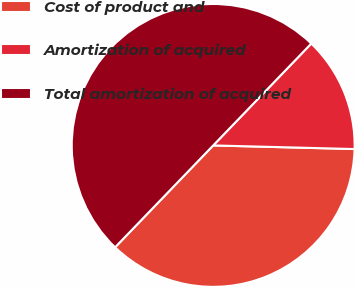Convert chart to OTSL. <chart><loc_0><loc_0><loc_500><loc_500><pie_chart><fcel>Cost of product and<fcel>Amortization of acquired<fcel>Total amortization of acquired<nl><fcel>36.79%<fcel>13.21%<fcel>50.0%<nl></chart> 